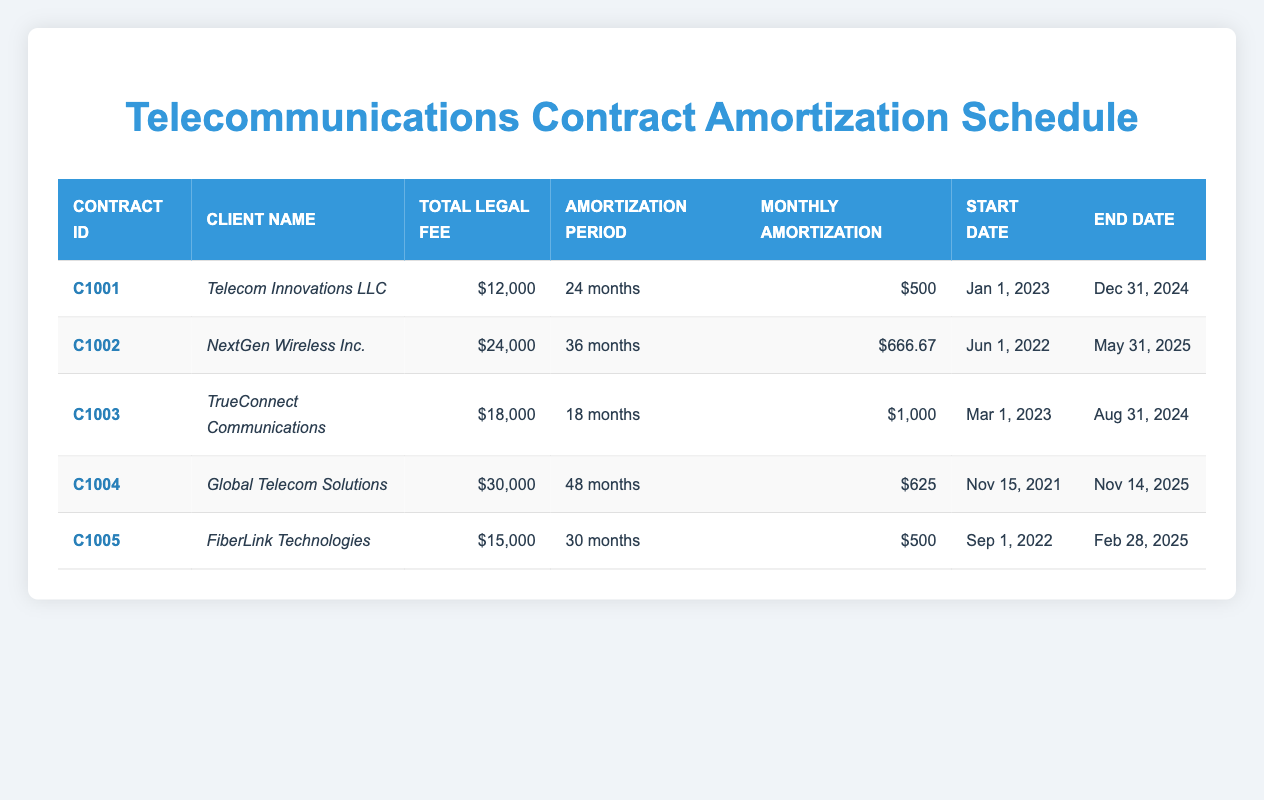What is the total legal fee for Global Telecom Solutions? The total legal fee for Global Telecom Solutions, as indicated in the table, is listed under the "Total Legal Fee" column next to the company's name. It shows $30,000.
Answer: $30,000 How many months is the amortization period for FiberLink Technologies? The amortization period for FiberLink Technologies is given in the "Amortization Period" column. It states that this contract has an amortization period of 30 months.
Answer: 30 months Which client has the highest monthly amortization? In the "Monthly Amortization" column, we can compare the amounts for each client. NextGen Wireless Inc. has a monthly amortization of $666.67, which is higher than the other clients.
Answer: NextGen Wireless Inc Is the start date for TrueConnect Communications before 2023? The start date for TrueConnect Communications is listed in the "Start Date" column as March 1, 2023. Since 2023 is not before 2023, this statement is false.
Answer: No What is the average total legal fee for all clients listed in the table? To calculate the average total legal fee, sum all the total legal fees: (12000 + 24000 + 18000 + 30000 + 15000) = 109000. Then divide by the number of clients which is 5: 109000 / 5 = 21800.
Answer: 21800 How many clients have an amortization period longer than 24 months? By examining the "Amortization Period" column, we find the clients with longer periods: NextGen Wireless Inc. (36 months), Global Telecom Solutions (48 months), and FiberLink Technologies (30 months). This totals 3 clients.
Answer: 3 Is the monthly amortization for Telecom Innovations LLC greater than $600? The monthly amortization for Telecom Innovations LLC is reported as $500 in the table, which is less than $600, making this statement false.
Answer: No What is the duration (in months) between the start date and end date for the contract with the longest amortization period? Checking the "Amortization Period" column, Global Telecom Solutions has the longest period at 48 months. The duration matches this value as it is the period defined for the contract.
Answer: 48 months 